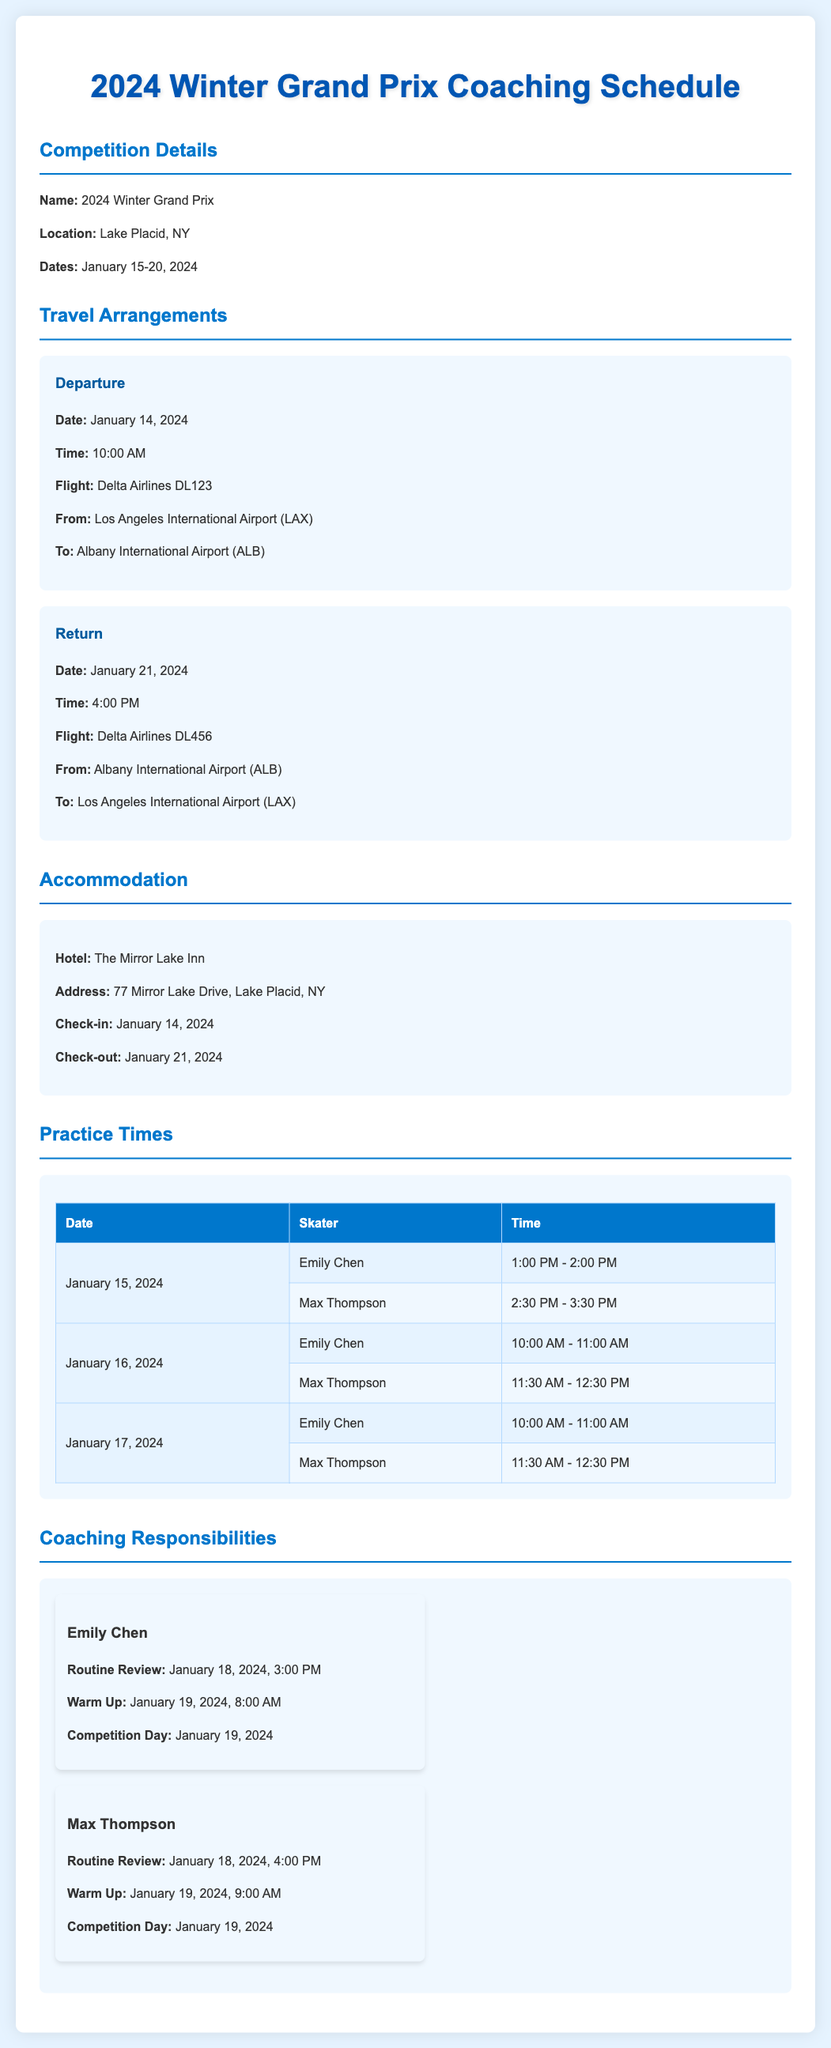What are the competition dates? The competition dates are specified in the document, detailing when the event will be held.
Answer: January 15-20, 2024 What time does the return flight depart? The return flight details in the travel arrangements section include the departure time.
Answer: 4:00 PM Who is responsible for the routine review on January 18? The coaching responsibilities outline who will have their routine reviewed on that date.
Answer: Max Thompson What is the name of the hotel? The accommodation section includes the name of the hotel where the team will stay.
Answer: The Mirror Lake Inn When is Emily Chen's warm-up scheduled? The coaching responsibilities table lists the time for Emily Chen's warm-up.
Answer: January 19, 2024, 8:00 AM What flight number is for the departure? The travel arrangements specify the flight number for the team's departure from Los Angeles.
Answer: Delta Airlines DL123 What hotel check-out date is listed? The accommodation details provide the date by which the hotel needs to be checked out.
Answer: January 21, 2024 How many skaters have practice on January 16? The practice times table reveals how many skaters are scheduled for practice on that date.
Answer: 2 